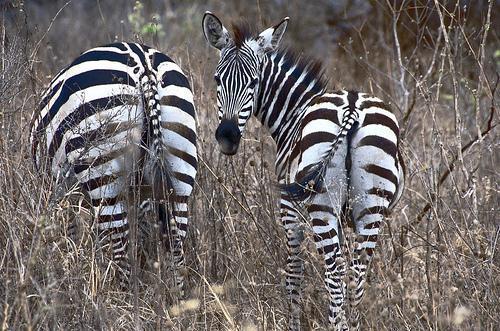How many zebras are there?
Give a very brief answer. 2. 